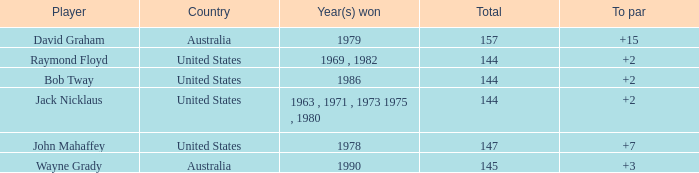How many strokes off par was the winner in 1978? 7.0. 